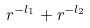Convert formula to latex. <formula><loc_0><loc_0><loc_500><loc_500>r ^ { - l _ { 1 } } + r ^ { - l _ { 2 } }</formula> 